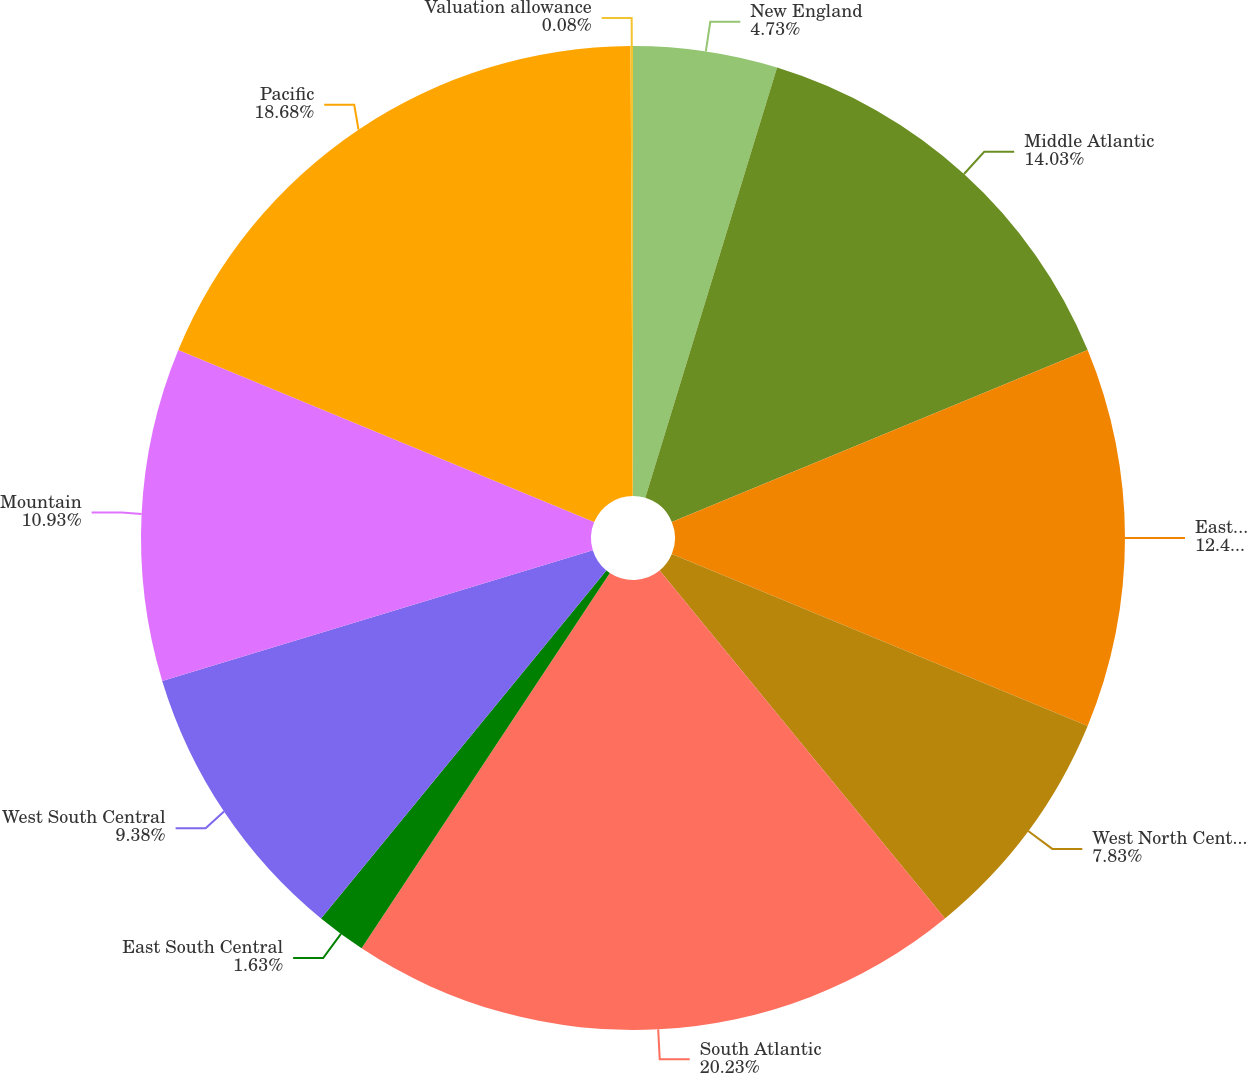Convert chart. <chart><loc_0><loc_0><loc_500><loc_500><pie_chart><fcel>New England<fcel>Middle Atlantic<fcel>East North Central<fcel>West North Central<fcel>South Atlantic<fcel>East South Central<fcel>West South Central<fcel>Mountain<fcel>Pacific<fcel>Valuation allowance<nl><fcel>4.73%<fcel>14.03%<fcel>12.48%<fcel>7.83%<fcel>20.23%<fcel>1.63%<fcel>9.38%<fcel>10.93%<fcel>18.68%<fcel>0.08%<nl></chart> 